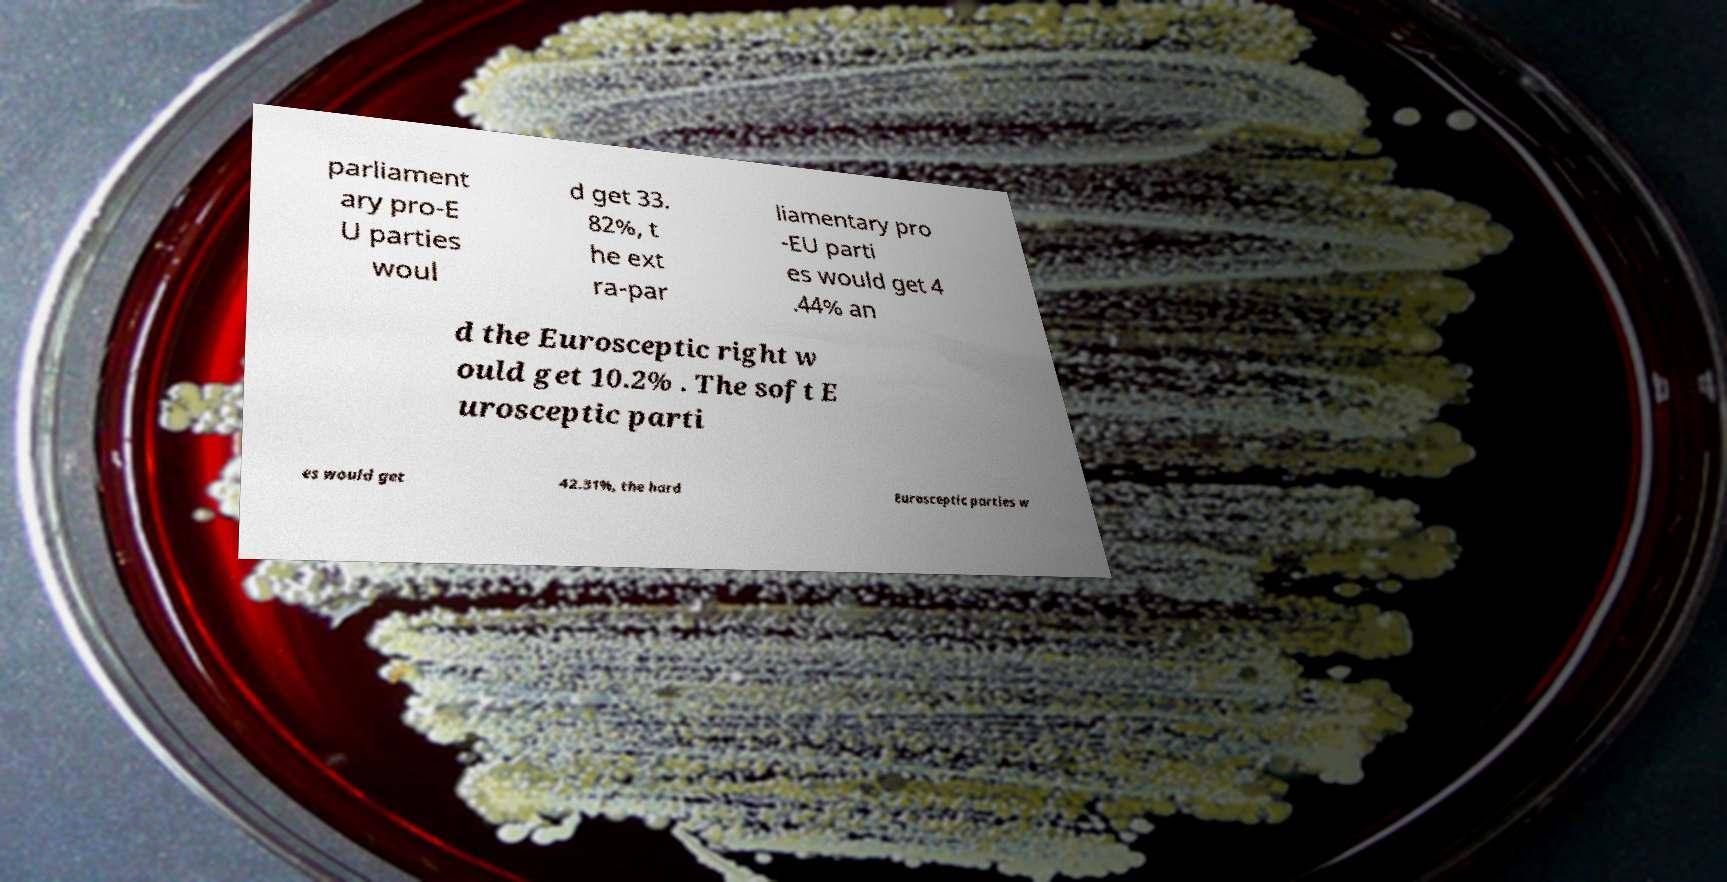I need the written content from this picture converted into text. Can you do that? parliament ary pro-E U parties woul d get 33. 82%, t he ext ra-par liamentary pro -EU parti es would get 4 .44% an d the Eurosceptic right w ould get 10.2% . The soft E urosceptic parti es would get 42.31%, the hard Eurosceptic parties w 